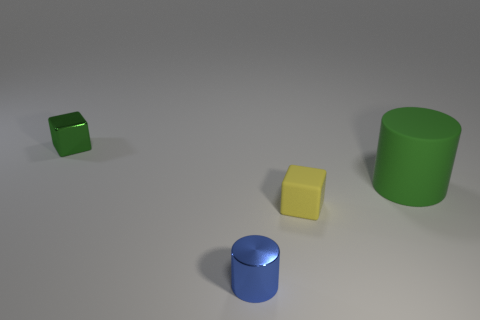Add 4 small metal cubes. How many objects exist? 8 Add 4 rubber blocks. How many rubber blocks exist? 5 Subtract 0 yellow cylinders. How many objects are left? 4 Subtract all brown matte cylinders. Subtract all blue shiny objects. How many objects are left? 3 Add 1 tiny green things. How many tiny green things are left? 2 